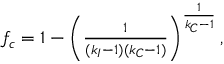Convert formula to latex. <formula><loc_0><loc_0><loc_500><loc_500>\begin{array} { r } { f _ { c } = 1 - \left ( \frac { 1 } { ( k _ { I } - 1 ) ( k _ { C } - 1 ) } \right ) ^ { \frac { 1 } { k _ { C } - 1 } } , } \end{array}</formula> 